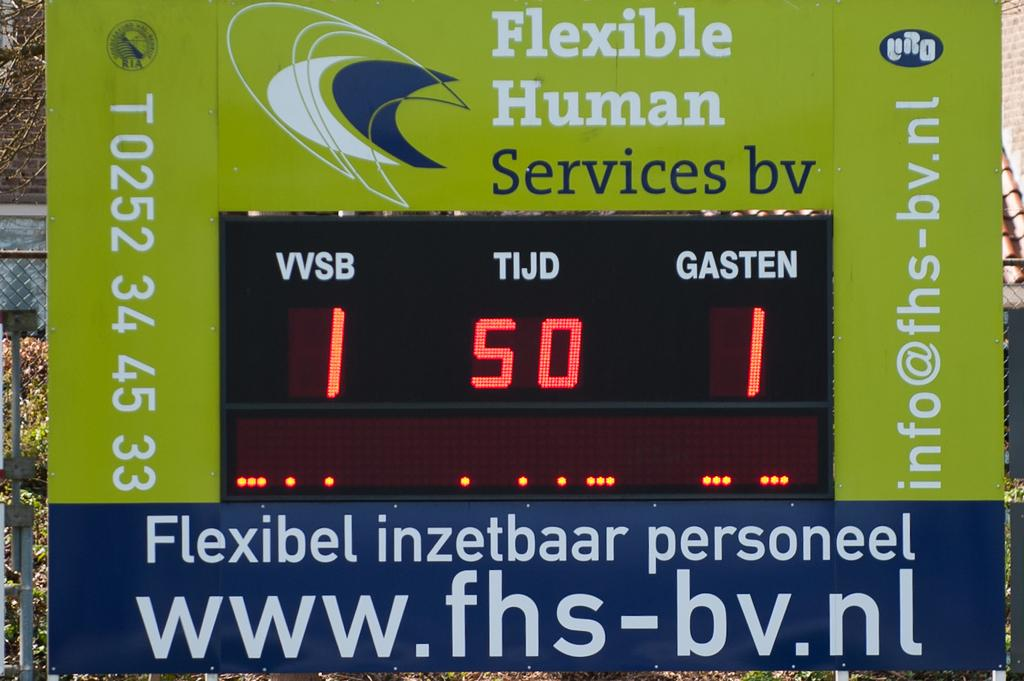<image>
Give a short and clear explanation of the subsequent image. A green and blue scoreboard sponsored by Flexible Human Services. 